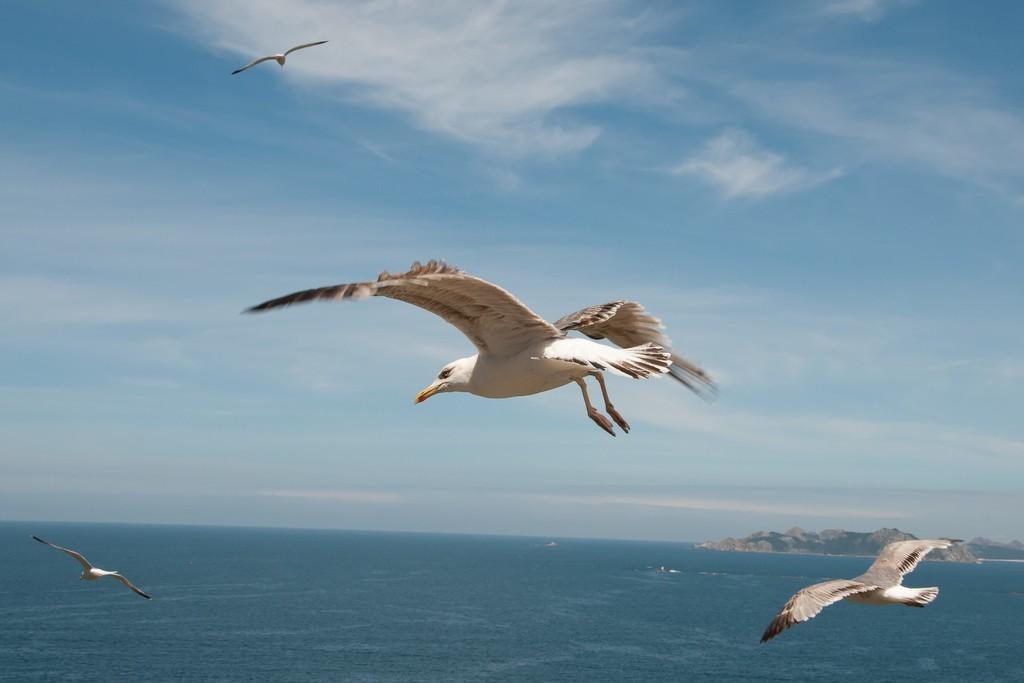In one or two sentences, can you explain what this image depicts? In the image there is a water surface and some mountains and there are few birds flying in the sky above the water surface. 